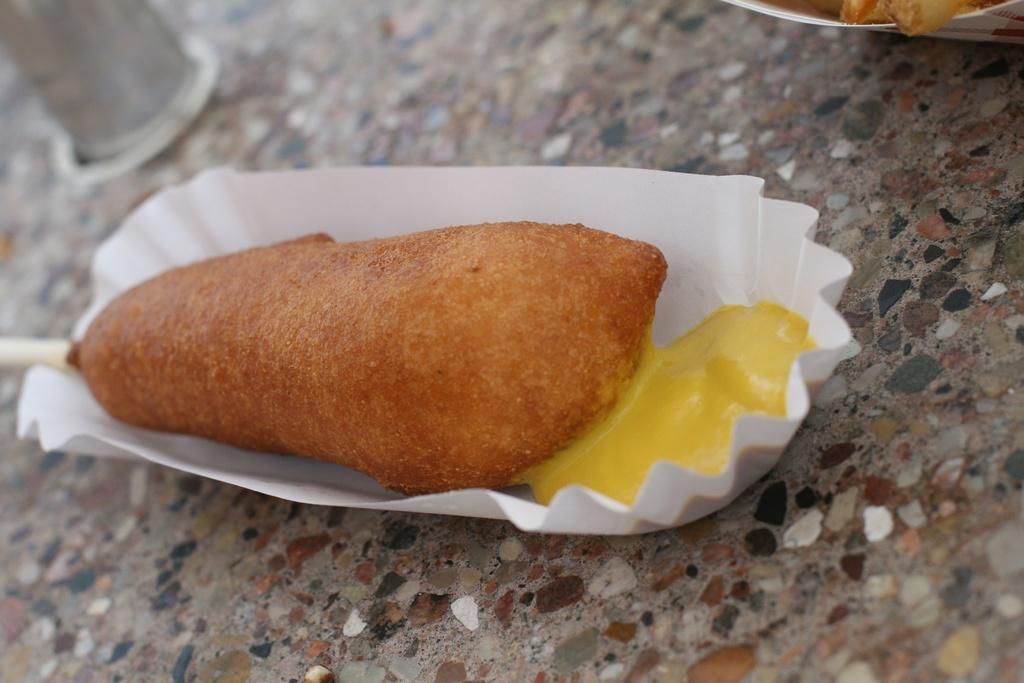Can you describe this image briefly? In this image, we can see a paper plate contains some food. 